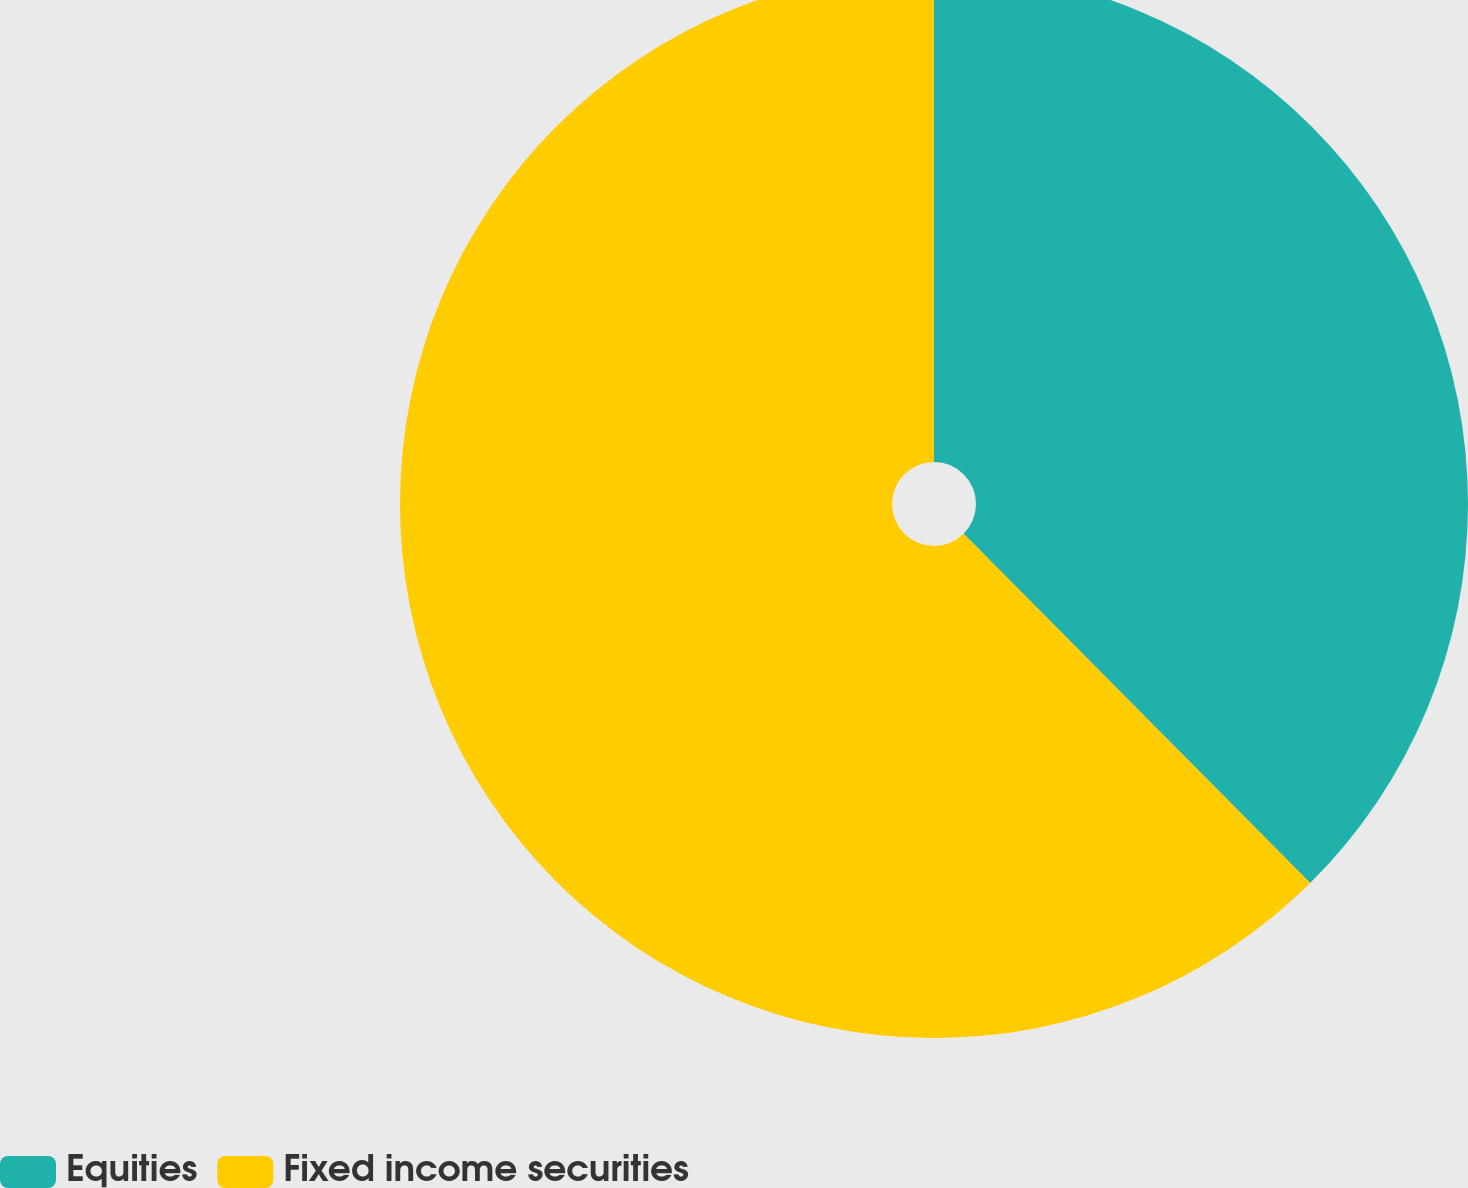<chart> <loc_0><loc_0><loc_500><loc_500><pie_chart><fcel>Equities<fcel>Fixed income securities<nl><fcel>37.56%<fcel>62.44%<nl></chart> 